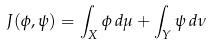Convert formula to latex. <formula><loc_0><loc_0><loc_500><loc_500>J ( \phi , \psi ) = \int _ { X } \phi \, d \mu + \int _ { Y } \psi \, d \nu</formula> 